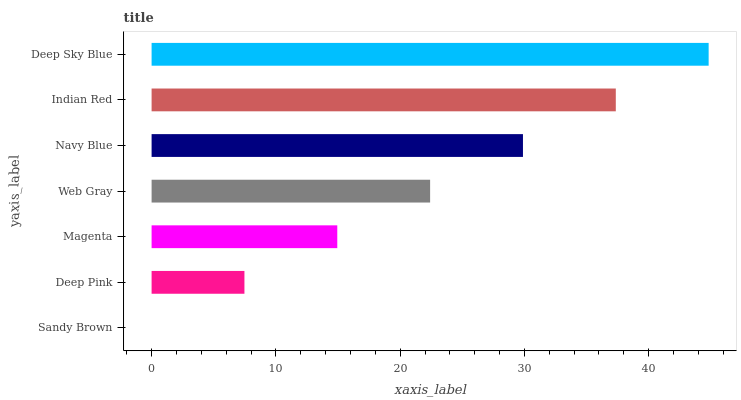Is Sandy Brown the minimum?
Answer yes or no. Yes. Is Deep Sky Blue the maximum?
Answer yes or no. Yes. Is Deep Pink the minimum?
Answer yes or no. No. Is Deep Pink the maximum?
Answer yes or no. No. Is Deep Pink greater than Sandy Brown?
Answer yes or no. Yes. Is Sandy Brown less than Deep Pink?
Answer yes or no. Yes. Is Sandy Brown greater than Deep Pink?
Answer yes or no. No. Is Deep Pink less than Sandy Brown?
Answer yes or no. No. Is Web Gray the high median?
Answer yes or no. Yes. Is Web Gray the low median?
Answer yes or no. Yes. Is Magenta the high median?
Answer yes or no. No. Is Magenta the low median?
Answer yes or no. No. 